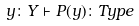<formula> <loc_0><loc_0><loc_500><loc_500>y \colon Y \vdash P ( y ) \colon T y p e</formula> 